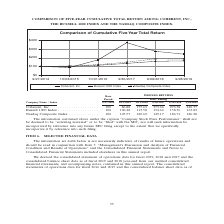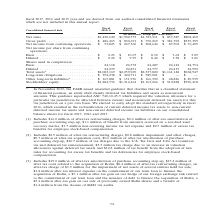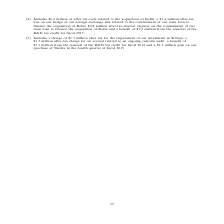According to Coherent's financial document, What does the amount for fiscal 2019 include? Includes $16.0 million of after-tax restructuring charges, $0.4 million of after-tax amortization of purchase accounting step-up, $1.1 million of benefit from amounts received on a resolved asset recovery matter, $1.7 million non-recurring income tax net expense and $2.5 million of excess tax benefits for employee stock-based compensation.. The document states: "(1) Includes $16.0 million of after-tax restructuring charges, $0.4 million of after-tax amortization of purchase accounting step-up, $1.1 million of ..." Also, What is the  Net sales for 2019? According to the financial document, $1,430,640 (in thousands). The relevant text states: "(in thousands, except per share data) Net sales . $1,430,640 $1,902,573 $1,723,311 $ 857,385 $802,460 Gross profit . $ 486,465 $ 830,691 $ 750,269 $ 381,392 $335..." Also, In which years was the selected financial data provided? The document contains multiple relevant values: 2019, 2018, 2017, 2016, 2015. From the document: "Fiscal Fiscal Consolidated financial data 2019(1) 2018(2) 2017(3) 2016(4) 2015(5) (in thousands, except per share data) Net sales . $1,430,640 $1,902,..." Additionally, In which year was the Diluted Net income per share from continuing operations largest? According to the financial document, 2018. The relevant text states: "Fiscal Fiscal Consolidated financial data 2019(1) 2018(2) 2017(3) 2016(4) 2015(5) (in thousands, except per share data) Net sales . $1,430,640 $1,902,573..." Also, can you calculate: What was the change in Diluted Net income per share from continuing operations in 2018 from 2017? Based on the calculation: 9.95-8.42, the result is 1.53. This is based on the information: "07 $ 8.52 $ 3.62 $ 3.09 Diluted . $ 2.22 $ 9.95 $ 8.42 $ 3.58 $ 3.06 Shares used in computation: Basic . 24,118 24,572 24,487 24,142 24,754 Diluted . 24,2 3 $ 10.07 $ 8.52 $ 3.62 $ 3.09 Diluted . $ 2...." The key data points involved are: 8.42, 9.95. Also, can you calculate: What was the percentage change in Diluted Net income per share from continuing operations in 2018 from 2017? To answer this question, I need to perform calculations using the financial data. The calculation is: (9.95-8.42)/8.42, which equals 18.17 (percentage). This is based on the information: "07 $ 8.52 $ 3.62 $ 3.09 Diluted . $ 2.22 $ 9.95 $ 8.42 $ 3.58 $ 3.06 Shares used in computation: Basic . 24,118 24,572 24,487 24,142 24,754 Diluted . 24,2 3 $ 10.07 $ 8.52 $ 3.62 $ 3.09 Diluted . $ 2...." The key data points involved are: 8.42, 9.95. 